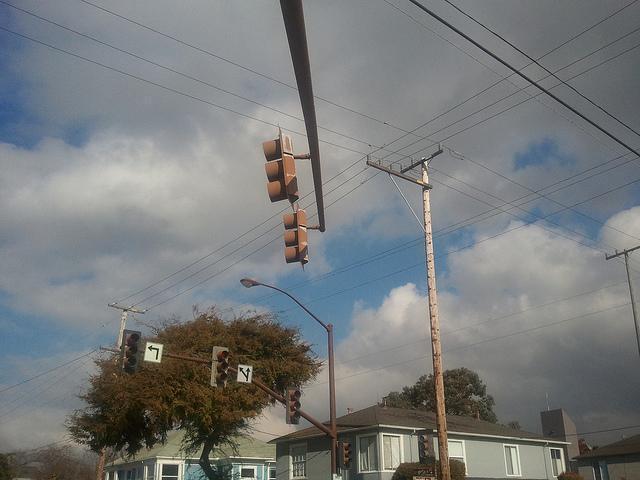How many cars are visible on this street?
Give a very brief answer. 0. How many toilets are there?
Give a very brief answer. 0. 